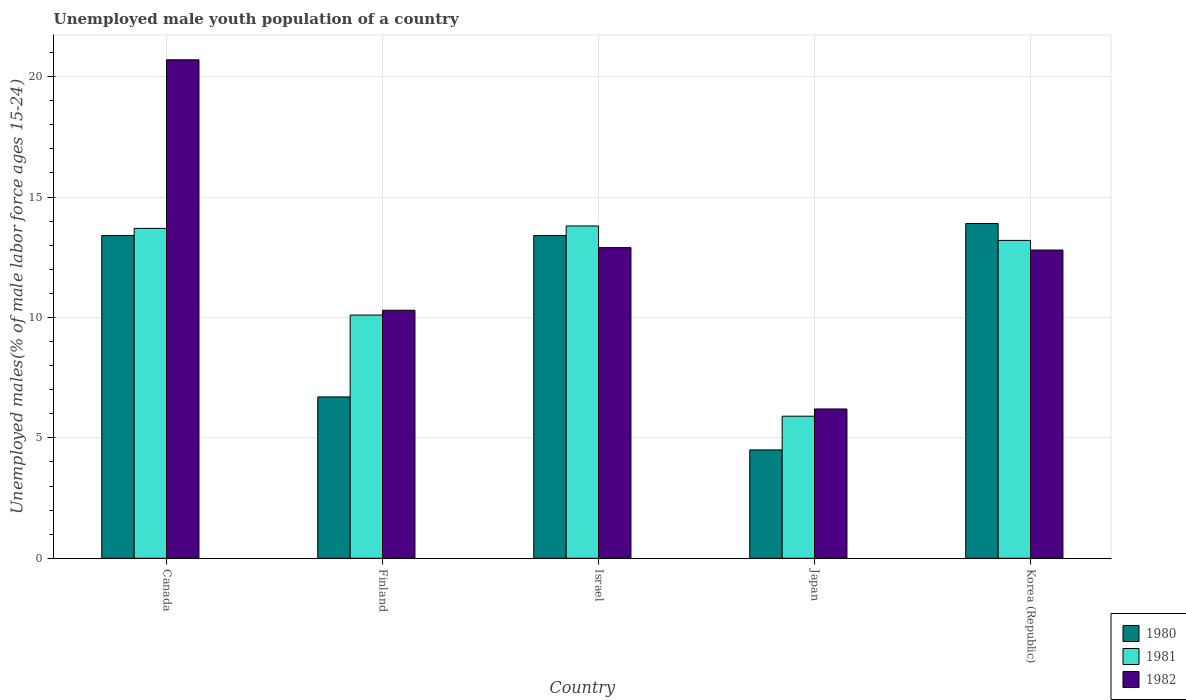In how many cases, is the number of bars for a given country not equal to the number of legend labels?
Ensure brevity in your answer.  0. What is the percentage of unemployed male youth population in 1981 in Canada?
Keep it short and to the point. 13.7. Across all countries, what is the maximum percentage of unemployed male youth population in 1980?
Keep it short and to the point. 13.9. Across all countries, what is the minimum percentage of unemployed male youth population in 1982?
Your answer should be very brief. 6.2. What is the total percentage of unemployed male youth population in 1981 in the graph?
Ensure brevity in your answer.  56.7. What is the difference between the percentage of unemployed male youth population in 1981 in Canada and that in Japan?
Ensure brevity in your answer.  7.8. What is the difference between the percentage of unemployed male youth population in 1980 in Israel and the percentage of unemployed male youth population in 1982 in Korea (Republic)?
Your answer should be very brief. 0.6. What is the average percentage of unemployed male youth population in 1981 per country?
Offer a terse response. 11.34. What is the difference between the percentage of unemployed male youth population of/in 1982 and percentage of unemployed male youth population of/in 1981 in Finland?
Keep it short and to the point. 0.2. What is the ratio of the percentage of unemployed male youth population in 1981 in Canada to that in Israel?
Offer a terse response. 0.99. What is the difference between the highest and the second highest percentage of unemployed male youth population in 1981?
Provide a short and direct response. -0.1. What is the difference between the highest and the lowest percentage of unemployed male youth population in 1982?
Provide a succinct answer. 14.5. In how many countries, is the percentage of unemployed male youth population in 1980 greater than the average percentage of unemployed male youth population in 1980 taken over all countries?
Provide a short and direct response. 3. Is the sum of the percentage of unemployed male youth population in 1980 in Finland and Japan greater than the maximum percentage of unemployed male youth population in 1981 across all countries?
Make the answer very short. No. Is it the case that in every country, the sum of the percentage of unemployed male youth population in 1982 and percentage of unemployed male youth population in 1981 is greater than the percentage of unemployed male youth population in 1980?
Provide a succinct answer. Yes. How many bars are there?
Provide a short and direct response. 15. Are the values on the major ticks of Y-axis written in scientific E-notation?
Your answer should be compact. No. Does the graph contain any zero values?
Ensure brevity in your answer.  No. Does the graph contain grids?
Offer a very short reply. Yes. How many legend labels are there?
Provide a short and direct response. 3. How are the legend labels stacked?
Give a very brief answer. Vertical. What is the title of the graph?
Offer a terse response. Unemployed male youth population of a country. Does "1973" appear as one of the legend labels in the graph?
Make the answer very short. No. What is the label or title of the Y-axis?
Make the answer very short. Unemployed males(% of male labor force ages 15-24). What is the Unemployed males(% of male labor force ages 15-24) in 1980 in Canada?
Provide a succinct answer. 13.4. What is the Unemployed males(% of male labor force ages 15-24) of 1981 in Canada?
Ensure brevity in your answer.  13.7. What is the Unemployed males(% of male labor force ages 15-24) of 1982 in Canada?
Your response must be concise. 20.7. What is the Unemployed males(% of male labor force ages 15-24) in 1980 in Finland?
Provide a short and direct response. 6.7. What is the Unemployed males(% of male labor force ages 15-24) of 1981 in Finland?
Provide a succinct answer. 10.1. What is the Unemployed males(% of male labor force ages 15-24) in 1982 in Finland?
Ensure brevity in your answer.  10.3. What is the Unemployed males(% of male labor force ages 15-24) in 1980 in Israel?
Ensure brevity in your answer.  13.4. What is the Unemployed males(% of male labor force ages 15-24) in 1981 in Israel?
Keep it short and to the point. 13.8. What is the Unemployed males(% of male labor force ages 15-24) in 1982 in Israel?
Offer a very short reply. 12.9. What is the Unemployed males(% of male labor force ages 15-24) of 1980 in Japan?
Your response must be concise. 4.5. What is the Unemployed males(% of male labor force ages 15-24) in 1981 in Japan?
Your answer should be very brief. 5.9. What is the Unemployed males(% of male labor force ages 15-24) in 1982 in Japan?
Provide a short and direct response. 6.2. What is the Unemployed males(% of male labor force ages 15-24) in 1980 in Korea (Republic)?
Give a very brief answer. 13.9. What is the Unemployed males(% of male labor force ages 15-24) in 1981 in Korea (Republic)?
Your answer should be compact. 13.2. What is the Unemployed males(% of male labor force ages 15-24) in 1982 in Korea (Republic)?
Provide a succinct answer. 12.8. Across all countries, what is the maximum Unemployed males(% of male labor force ages 15-24) of 1980?
Keep it short and to the point. 13.9. Across all countries, what is the maximum Unemployed males(% of male labor force ages 15-24) in 1981?
Your response must be concise. 13.8. Across all countries, what is the maximum Unemployed males(% of male labor force ages 15-24) of 1982?
Your answer should be compact. 20.7. Across all countries, what is the minimum Unemployed males(% of male labor force ages 15-24) in 1980?
Provide a succinct answer. 4.5. Across all countries, what is the minimum Unemployed males(% of male labor force ages 15-24) in 1981?
Offer a terse response. 5.9. Across all countries, what is the minimum Unemployed males(% of male labor force ages 15-24) in 1982?
Provide a succinct answer. 6.2. What is the total Unemployed males(% of male labor force ages 15-24) in 1980 in the graph?
Give a very brief answer. 51.9. What is the total Unemployed males(% of male labor force ages 15-24) of 1981 in the graph?
Your answer should be compact. 56.7. What is the total Unemployed males(% of male labor force ages 15-24) in 1982 in the graph?
Give a very brief answer. 62.9. What is the difference between the Unemployed males(% of male labor force ages 15-24) of 1981 in Canada and that in Finland?
Offer a terse response. 3.6. What is the difference between the Unemployed males(% of male labor force ages 15-24) in 1982 in Canada and that in Finland?
Offer a terse response. 10.4. What is the difference between the Unemployed males(% of male labor force ages 15-24) in 1980 in Canada and that in Israel?
Ensure brevity in your answer.  0. What is the difference between the Unemployed males(% of male labor force ages 15-24) in 1982 in Canada and that in Israel?
Keep it short and to the point. 7.8. What is the difference between the Unemployed males(% of male labor force ages 15-24) of 1980 in Canada and that in Japan?
Your answer should be compact. 8.9. What is the difference between the Unemployed males(% of male labor force ages 15-24) of 1982 in Canada and that in Japan?
Your answer should be very brief. 14.5. What is the difference between the Unemployed males(% of male labor force ages 15-24) of 1980 in Canada and that in Korea (Republic)?
Provide a succinct answer. -0.5. What is the difference between the Unemployed males(% of male labor force ages 15-24) in 1981 in Canada and that in Korea (Republic)?
Give a very brief answer. 0.5. What is the difference between the Unemployed males(% of male labor force ages 15-24) of 1982 in Canada and that in Korea (Republic)?
Your answer should be compact. 7.9. What is the difference between the Unemployed males(% of male labor force ages 15-24) of 1980 in Finland and that in Israel?
Give a very brief answer. -6.7. What is the difference between the Unemployed males(% of male labor force ages 15-24) of 1981 in Finland and that in Israel?
Keep it short and to the point. -3.7. What is the difference between the Unemployed males(% of male labor force ages 15-24) in 1982 in Finland and that in Israel?
Your answer should be compact. -2.6. What is the difference between the Unemployed males(% of male labor force ages 15-24) in 1980 in Finland and that in Japan?
Provide a succinct answer. 2.2. What is the difference between the Unemployed males(% of male labor force ages 15-24) of 1982 in Finland and that in Japan?
Provide a succinct answer. 4.1. What is the difference between the Unemployed males(% of male labor force ages 15-24) of 1980 in Finland and that in Korea (Republic)?
Offer a terse response. -7.2. What is the difference between the Unemployed males(% of male labor force ages 15-24) of 1981 in Finland and that in Korea (Republic)?
Your answer should be compact. -3.1. What is the difference between the Unemployed males(% of male labor force ages 15-24) of 1982 in Finland and that in Korea (Republic)?
Provide a short and direct response. -2.5. What is the difference between the Unemployed males(% of male labor force ages 15-24) of 1980 in Israel and that in Japan?
Give a very brief answer. 8.9. What is the difference between the Unemployed males(% of male labor force ages 15-24) of 1981 in Israel and that in Korea (Republic)?
Offer a terse response. 0.6. What is the difference between the Unemployed males(% of male labor force ages 15-24) of 1982 in Israel and that in Korea (Republic)?
Offer a very short reply. 0.1. What is the difference between the Unemployed males(% of male labor force ages 15-24) in 1981 in Japan and that in Korea (Republic)?
Keep it short and to the point. -7.3. What is the difference between the Unemployed males(% of male labor force ages 15-24) in 1980 in Canada and the Unemployed males(% of male labor force ages 15-24) in 1981 in Finland?
Your answer should be compact. 3.3. What is the difference between the Unemployed males(% of male labor force ages 15-24) in 1981 in Canada and the Unemployed males(% of male labor force ages 15-24) in 1982 in Finland?
Ensure brevity in your answer.  3.4. What is the difference between the Unemployed males(% of male labor force ages 15-24) in 1981 in Canada and the Unemployed males(% of male labor force ages 15-24) in 1982 in Israel?
Your answer should be very brief. 0.8. What is the difference between the Unemployed males(% of male labor force ages 15-24) in 1980 in Canada and the Unemployed males(% of male labor force ages 15-24) in 1982 in Japan?
Give a very brief answer. 7.2. What is the difference between the Unemployed males(% of male labor force ages 15-24) of 1981 in Canada and the Unemployed males(% of male labor force ages 15-24) of 1982 in Japan?
Provide a short and direct response. 7.5. What is the difference between the Unemployed males(% of male labor force ages 15-24) of 1980 in Canada and the Unemployed males(% of male labor force ages 15-24) of 1981 in Korea (Republic)?
Your answer should be compact. 0.2. What is the difference between the Unemployed males(% of male labor force ages 15-24) of 1981 in Canada and the Unemployed males(% of male labor force ages 15-24) of 1982 in Korea (Republic)?
Ensure brevity in your answer.  0.9. What is the difference between the Unemployed males(% of male labor force ages 15-24) in 1980 in Finland and the Unemployed males(% of male labor force ages 15-24) in 1981 in Israel?
Your response must be concise. -7.1. What is the difference between the Unemployed males(% of male labor force ages 15-24) in 1980 in Finland and the Unemployed males(% of male labor force ages 15-24) in 1982 in Korea (Republic)?
Give a very brief answer. -6.1. What is the difference between the Unemployed males(% of male labor force ages 15-24) of 1980 in Israel and the Unemployed males(% of male labor force ages 15-24) of 1982 in Japan?
Offer a terse response. 7.2. What is the difference between the Unemployed males(% of male labor force ages 15-24) in 1981 in Israel and the Unemployed males(% of male labor force ages 15-24) in 1982 in Japan?
Your answer should be very brief. 7.6. What is the difference between the Unemployed males(% of male labor force ages 15-24) in 1980 in Israel and the Unemployed males(% of male labor force ages 15-24) in 1981 in Korea (Republic)?
Ensure brevity in your answer.  0.2. What is the difference between the Unemployed males(% of male labor force ages 15-24) in 1980 in Israel and the Unemployed males(% of male labor force ages 15-24) in 1982 in Korea (Republic)?
Your answer should be compact. 0.6. What is the difference between the Unemployed males(% of male labor force ages 15-24) in 1980 in Japan and the Unemployed males(% of male labor force ages 15-24) in 1981 in Korea (Republic)?
Keep it short and to the point. -8.7. What is the difference between the Unemployed males(% of male labor force ages 15-24) in 1980 in Japan and the Unemployed males(% of male labor force ages 15-24) in 1982 in Korea (Republic)?
Keep it short and to the point. -8.3. What is the difference between the Unemployed males(% of male labor force ages 15-24) of 1981 in Japan and the Unemployed males(% of male labor force ages 15-24) of 1982 in Korea (Republic)?
Give a very brief answer. -6.9. What is the average Unemployed males(% of male labor force ages 15-24) of 1980 per country?
Provide a short and direct response. 10.38. What is the average Unemployed males(% of male labor force ages 15-24) in 1981 per country?
Ensure brevity in your answer.  11.34. What is the average Unemployed males(% of male labor force ages 15-24) in 1982 per country?
Give a very brief answer. 12.58. What is the difference between the Unemployed males(% of male labor force ages 15-24) in 1980 and Unemployed males(% of male labor force ages 15-24) in 1982 in Finland?
Your answer should be compact. -3.6. What is the difference between the Unemployed males(% of male labor force ages 15-24) of 1981 and Unemployed males(% of male labor force ages 15-24) of 1982 in Finland?
Offer a very short reply. -0.2. What is the difference between the Unemployed males(% of male labor force ages 15-24) in 1980 and Unemployed males(% of male labor force ages 15-24) in 1981 in Korea (Republic)?
Your answer should be compact. 0.7. What is the difference between the Unemployed males(% of male labor force ages 15-24) of 1981 and Unemployed males(% of male labor force ages 15-24) of 1982 in Korea (Republic)?
Offer a very short reply. 0.4. What is the ratio of the Unemployed males(% of male labor force ages 15-24) of 1981 in Canada to that in Finland?
Your answer should be compact. 1.36. What is the ratio of the Unemployed males(% of male labor force ages 15-24) in 1982 in Canada to that in Finland?
Keep it short and to the point. 2.01. What is the ratio of the Unemployed males(% of male labor force ages 15-24) of 1982 in Canada to that in Israel?
Offer a terse response. 1.6. What is the ratio of the Unemployed males(% of male labor force ages 15-24) in 1980 in Canada to that in Japan?
Offer a very short reply. 2.98. What is the ratio of the Unemployed males(% of male labor force ages 15-24) in 1981 in Canada to that in Japan?
Your response must be concise. 2.32. What is the ratio of the Unemployed males(% of male labor force ages 15-24) of 1982 in Canada to that in Japan?
Offer a terse response. 3.34. What is the ratio of the Unemployed males(% of male labor force ages 15-24) of 1981 in Canada to that in Korea (Republic)?
Make the answer very short. 1.04. What is the ratio of the Unemployed males(% of male labor force ages 15-24) of 1982 in Canada to that in Korea (Republic)?
Ensure brevity in your answer.  1.62. What is the ratio of the Unemployed males(% of male labor force ages 15-24) of 1980 in Finland to that in Israel?
Your response must be concise. 0.5. What is the ratio of the Unemployed males(% of male labor force ages 15-24) in 1981 in Finland to that in Israel?
Ensure brevity in your answer.  0.73. What is the ratio of the Unemployed males(% of male labor force ages 15-24) in 1982 in Finland to that in Israel?
Your answer should be very brief. 0.8. What is the ratio of the Unemployed males(% of male labor force ages 15-24) of 1980 in Finland to that in Japan?
Provide a succinct answer. 1.49. What is the ratio of the Unemployed males(% of male labor force ages 15-24) in 1981 in Finland to that in Japan?
Provide a succinct answer. 1.71. What is the ratio of the Unemployed males(% of male labor force ages 15-24) of 1982 in Finland to that in Japan?
Your answer should be compact. 1.66. What is the ratio of the Unemployed males(% of male labor force ages 15-24) in 1980 in Finland to that in Korea (Republic)?
Your answer should be very brief. 0.48. What is the ratio of the Unemployed males(% of male labor force ages 15-24) in 1981 in Finland to that in Korea (Republic)?
Make the answer very short. 0.77. What is the ratio of the Unemployed males(% of male labor force ages 15-24) of 1982 in Finland to that in Korea (Republic)?
Offer a terse response. 0.8. What is the ratio of the Unemployed males(% of male labor force ages 15-24) in 1980 in Israel to that in Japan?
Provide a succinct answer. 2.98. What is the ratio of the Unemployed males(% of male labor force ages 15-24) of 1981 in Israel to that in Japan?
Make the answer very short. 2.34. What is the ratio of the Unemployed males(% of male labor force ages 15-24) in 1982 in Israel to that in Japan?
Your answer should be compact. 2.08. What is the ratio of the Unemployed males(% of male labor force ages 15-24) of 1980 in Israel to that in Korea (Republic)?
Make the answer very short. 0.96. What is the ratio of the Unemployed males(% of male labor force ages 15-24) in 1981 in Israel to that in Korea (Republic)?
Keep it short and to the point. 1.05. What is the ratio of the Unemployed males(% of male labor force ages 15-24) in 1980 in Japan to that in Korea (Republic)?
Your answer should be compact. 0.32. What is the ratio of the Unemployed males(% of male labor force ages 15-24) in 1981 in Japan to that in Korea (Republic)?
Your answer should be very brief. 0.45. What is the ratio of the Unemployed males(% of male labor force ages 15-24) in 1982 in Japan to that in Korea (Republic)?
Your answer should be very brief. 0.48. What is the difference between the highest and the second highest Unemployed males(% of male labor force ages 15-24) in 1981?
Your answer should be compact. 0.1. What is the difference between the highest and the second highest Unemployed males(% of male labor force ages 15-24) of 1982?
Give a very brief answer. 7.8. What is the difference between the highest and the lowest Unemployed males(% of male labor force ages 15-24) of 1980?
Make the answer very short. 9.4. What is the difference between the highest and the lowest Unemployed males(% of male labor force ages 15-24) of 1981?
Make the answer very short. 7.9. What is the difference between the highest and the lowest Unemployed males(% of male labor force ages 15-24) of 1982?
Your response must be concise. 14.5. 